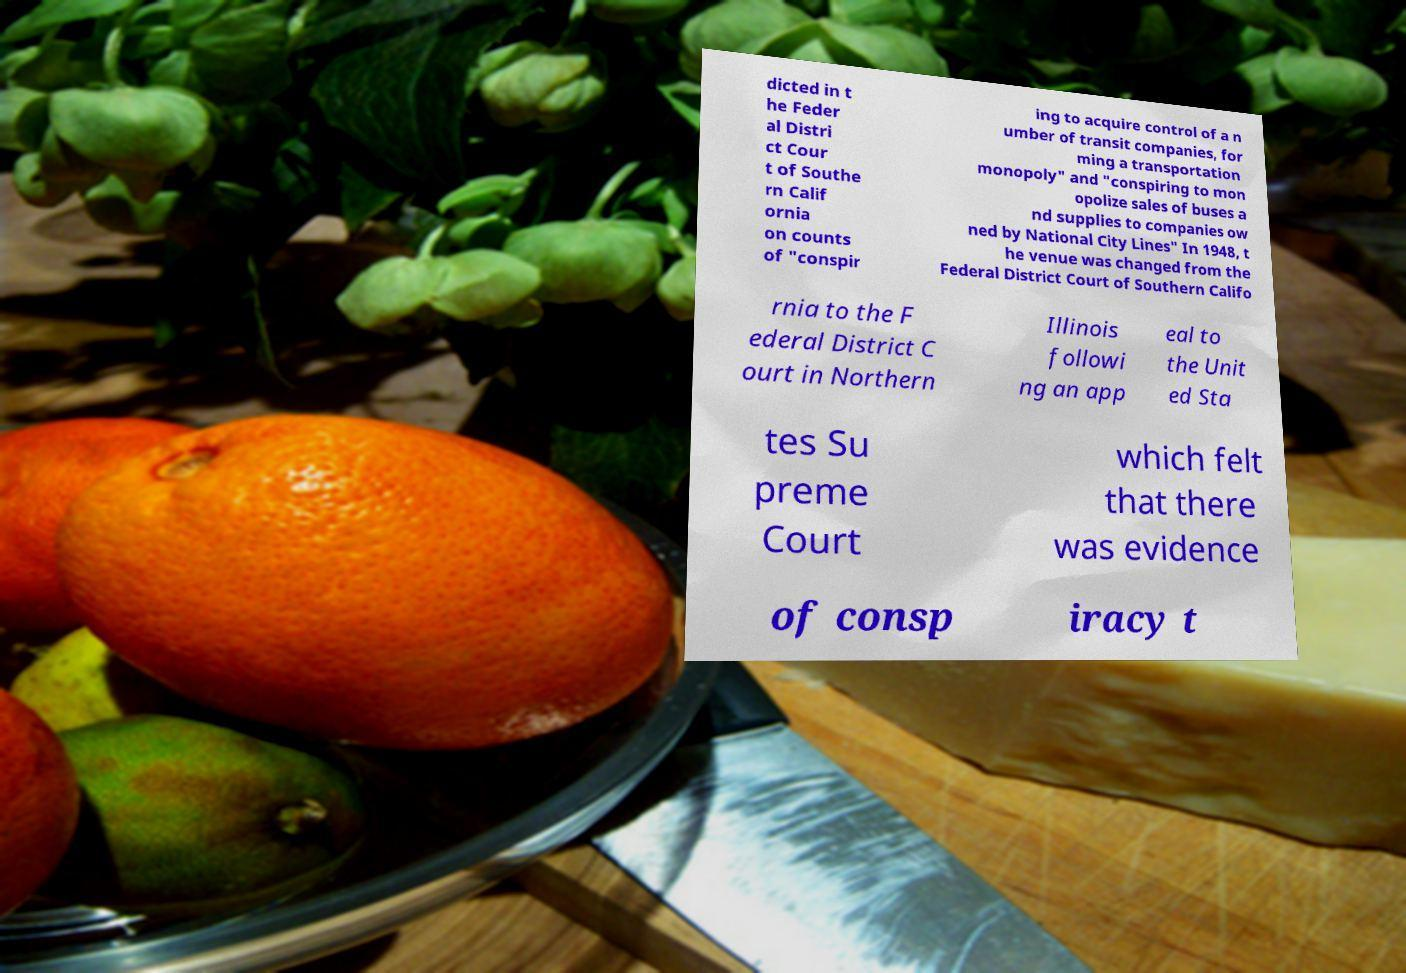What messages or text are displayed in this image? I need them in a readable, typed format. dicted in t he Feder al Distri ct Cour t of Southe rn Calif ornia on counts of "conspir ing to acquire control of a n umber of transit companies, for ming a transportation monopoly" and "conspiring to mon opolize sales of buses a nd supplies to companies ow ned by National City Lines" In 1948, t he venue was changed from the Federal District Court of Southern Califo rnia to the F ederal District C ourt in Northern Illinois followi ng an app eal to the Unit ed Sta tes Su preme Court which felt that there was evidence of consp iracy t 